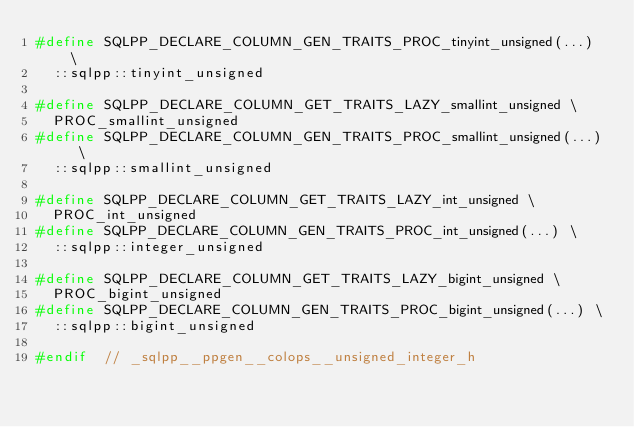<code> <loc_0><loc_0><loc_500><loc_500><_C_>#define SQLPP_DECLARE_COLUMN_GEN_TRAITS_PROC_tinyint_unsigned(...) \
  ::sqlpp::tinyint_unsigned

#define SQLPP_DECLARE_COLUMN_GET_TRAITS_LAZY_smallint_unsigned \
  PROC_smallint_unsigned
#define SQLPP_DECLARE_COLUMN_GEN_TRAITS_PROC_smallint_unsigned(...) \
  ::sqlpp::smallint_unsigned

#define SQLPP_DECLARE_COLUMN_GET_TRAITS_LAZY_int_unsigned \
  PROC_int_unsigned
#define SQLPP_DECLARE_COLUMN_GEN_TRAITS_PROC_int_unsigned(...) \
  ::sqlpp::integer_unsigned

#define SQLPP_DECLARE_COLUMN_GET_TRAITS_LAZY_bigint_unsigned \
  PROC_bigint_unsigned
#define SQLPP_DECLARE_COLUMN_GEN_TRAITS_PROC_bigint_unsigned(...) \
  ::sqlpp::bigint_unsigned

#endif  // _sqlpp__ppgen__colops__unsigned_integer_h
</code> 